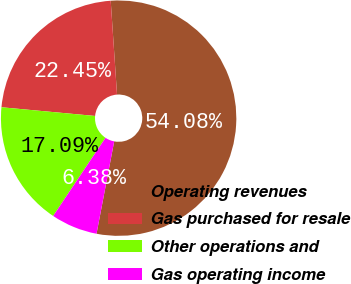Convert chart to OTSL. <chart><loc_0><loc_0><loc_500><loc_500><pie_chart><fcel>Operating revenues<fcel>Gas purchased for resale<fcel>Other operations and<fcel>Gas operating income<nl><fcel>54.08%<fcel>22.45%<fcel>17.09%<fcel>6.38%<nl></chart> 